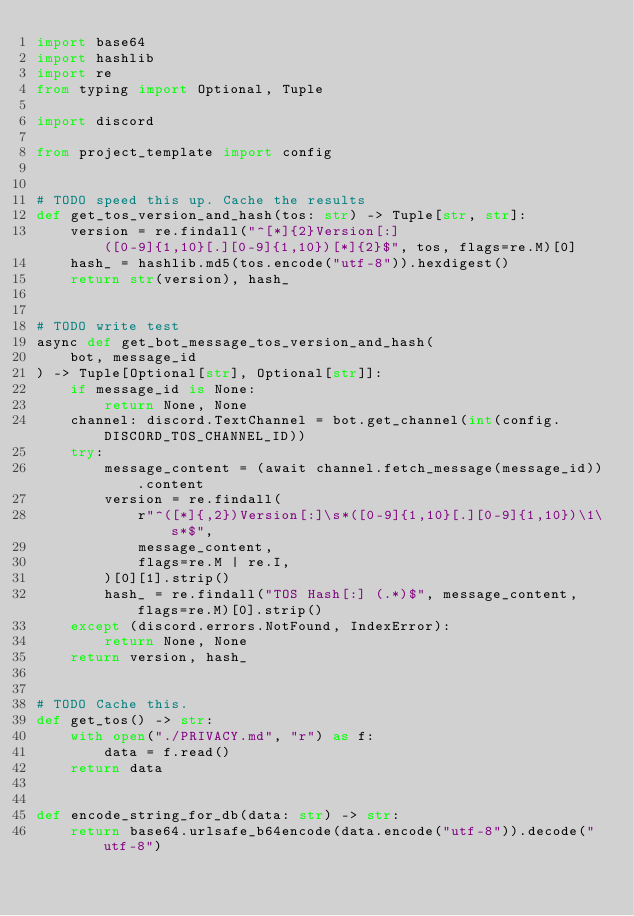Convert code to text. <code><loc_0><loc_0><loc_500><loc_500><_Python_>import base64
import hashlib
import re
from typing import Optional, Tuple

import discord

from project_template import config


# TODO speed this up. Cache the results
def get_tos_version_and_hash(tos: str) -> Tuple[str, str]:
    version = re.findall("^[*]{2}Version[:] ([0-9]{1,10}[.][0-9]{1,10})[*]{2}$", tos, flags=re.M)[0]
    hash_ = hashlib.md5(tos.encode("utf-8")).hexdigest()
    return str(version), hash_


# TODO write test
async def get_bot_message_tos_version_and_hash(
    bot, message_id
) -> Tuple[Optional[str], Optional[str]]:
    if message_id is None:
        return None, None
    channel: discord.TextChannel = bot.get_channel(int(config.DISCORD_TOS_CHANNEL_ID))
    try:
        message_content = (await channel.fetch_message(message_id)).content
        version = re.findall(
            r"^([*]{,2})Version[:]\s*([0-9]{1,10}[.][0-9]{1,10})\1\s*$",
            message_content,
            flags=re.M | re.I,
        )[0][1].strip()
        hash_ = re.findall("TOS Hash[:] (.*)$", message_content, flags=re.M)[0].strip()
    except (discord.errors.NotFound, IndexError):
        return None, None
    return version, hash_


# TODO Cache this.
def get_tos() -> str:
    with open("./PRIVACY.md", "r") as f:
        data = f.read()
    return data


def encode_string_for_db(data: str) -> str:
    return base64.urlsafe_b64encode(data.encode("utf-8")).decode("utf-8")
</code> 